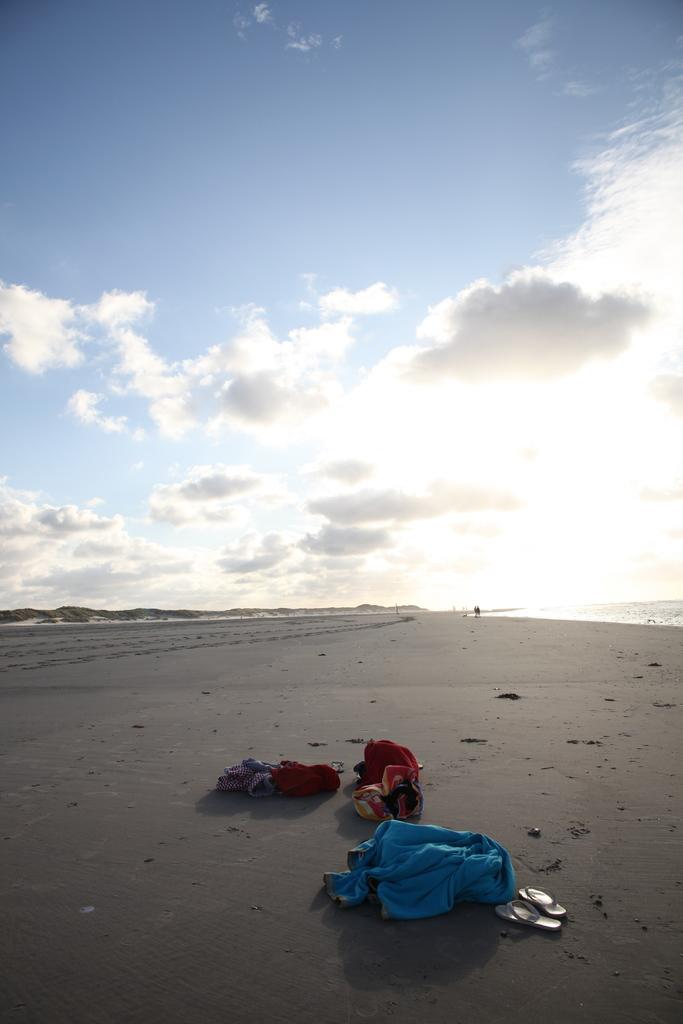What is on the seaside sand in the image? There are clothes on the seaside sand. What can be seen besides the clothes on the sand? There is sea water visible in the image. How would you describe the sky in the image? The sky is cloudy in the image. What type of wine is being served in the alley in the image? There is no alley or wine present in the image; it features clothes on the seaside sand with sea water and a cloudy sky. 